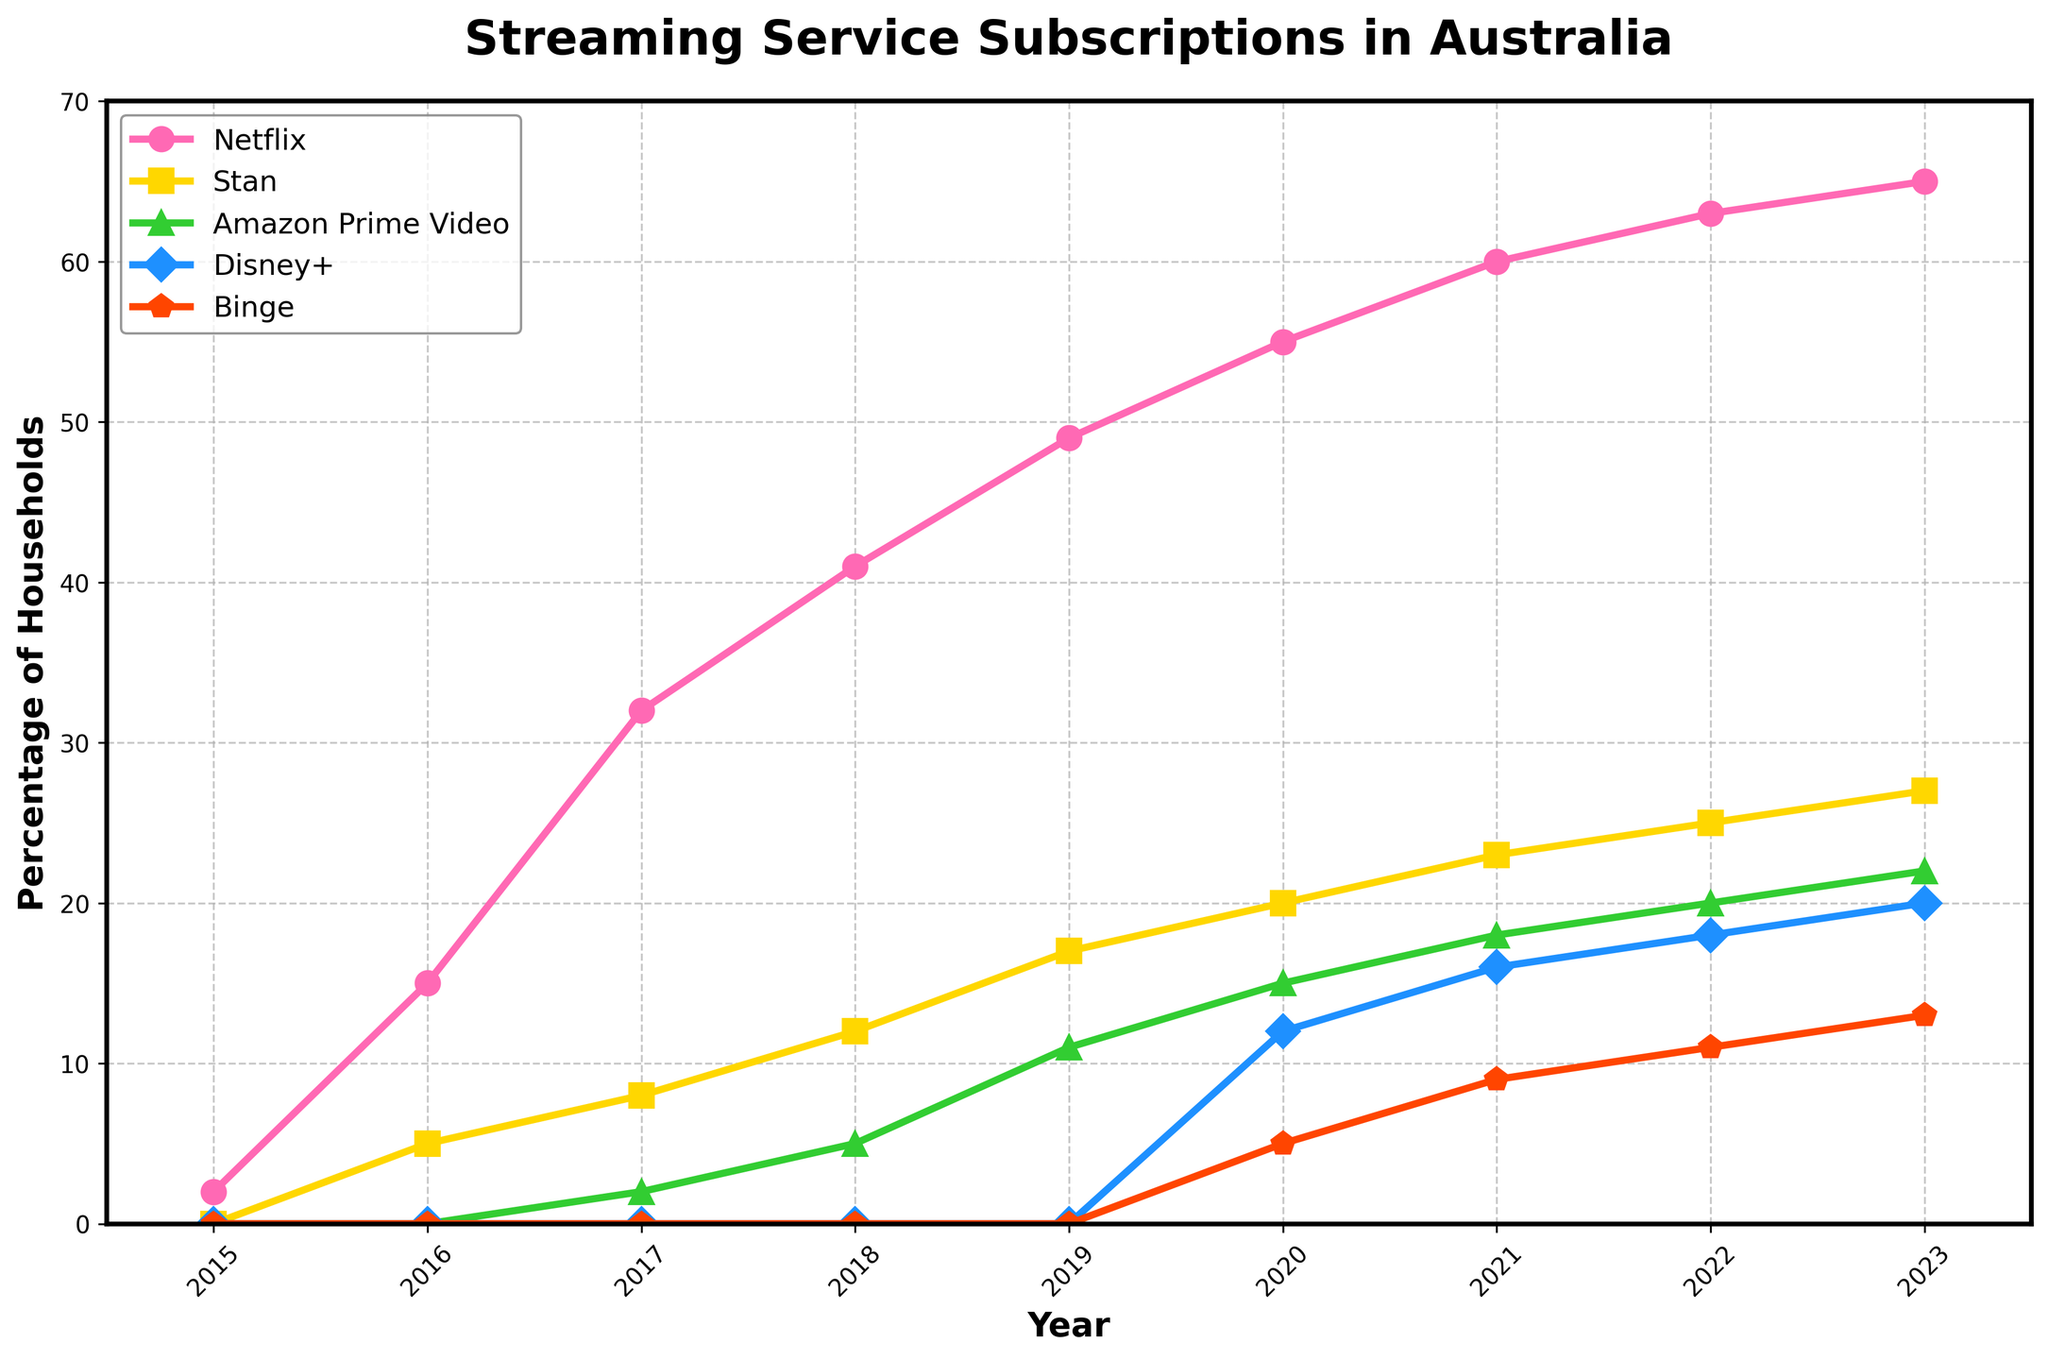What streaming service had the highest percentage of Australian households subscribed in 2018? By looking at the percentages for each streaming service in the year 2018 on the plot, Netflix has the highest percentage, which is 41%.
Answer: Netflix Which service saw the most significant increase in percentage from 2018 to 2019? To find this, first, calculate the percentage increase for each service between the two years. For Netflix, it's (49-41)=8. For Stan, it's (17-12)=5. For Amazon Prime Video, it's (11-5)=6. The highest increase observed here is 8 for Netflix.
Answer: Netflix What year did Disney+ start showing up on the chart? By inspecting the plot, Disney+ first appears in the year 2020 with a percentage of 12.
Answer: 2020 Compare the percentage of households with Amazon Prime Video and Stan subscriptions in 2017. Which one had a higher percentage? In 2017, according to the chart, Amazon Prime Video has 2%, while Stan has 8%. Therefore, Stan has a higher percentage.
Answer: Stan How much higher was Netflix's percentage compared to Binge in 2023? In 2023, Netflix has 65%, and Binge has 13%. The difference is 65-13 = 52%.
Answer: 52% What is the average percentage of households with Stan subscriptions from 2016 to 2020 inclusive? Calculate the average by summing the Stan percentages from 2016 to 2020 and dividing by the number of years: (5+8+12+17+20)/5 = 62/5 = 12.4%.
Answer: 12.4% Which streaming service shows a consistent increase, without any dips, from 2015 to 2023? By observing the trends of each service in the chart, Netflix is the only one that consistently increases every year without any dips.
Answer: Netflix In what range of years did Binge see the most rapid growth? To determine the rapid growth, look for the steepest slope in Binge’s line. The most significant increment happens between 2020 (5%) and 2021 (9%), which suggests the rapid growth was observed during this period.
Answer: 2020-2021 